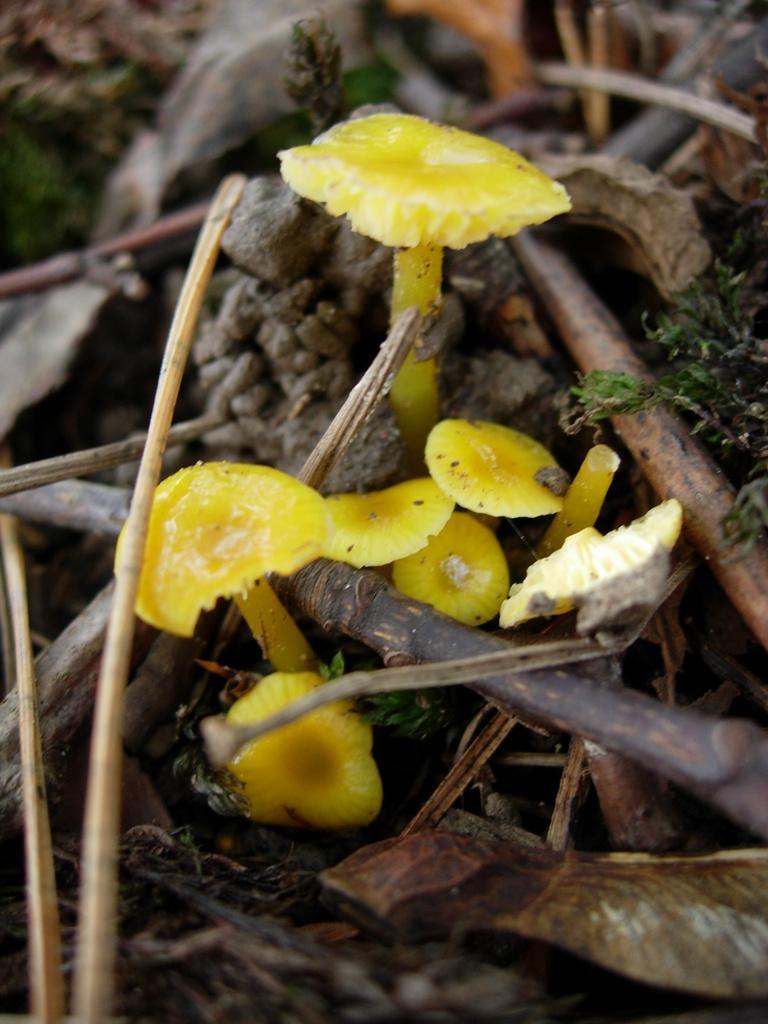Could you give a brief overview of what you see in this image? In this image, we can see mushrooms, logs and some plants. 